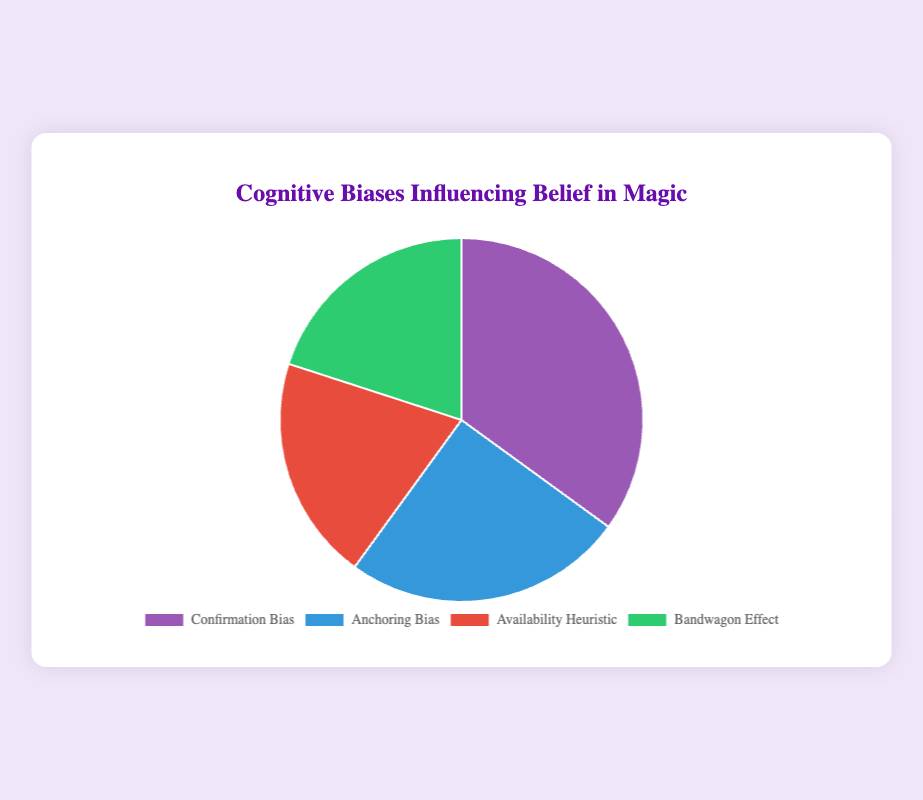What percentage of people are influenced by Confirmation Bias in their belief in magic? The percentage influenced by Confirmation Bias is indicated directly in the pie chart. According to the chart, it shows a slice labeled Confirmation Bias with this value.
Answer: 35% What is the total percentage of people influenced by Availability Heuristic and Bandwagon Effect combined? To find the combined percentage, add the two individual percentages: 20% (Availability Heuristic) + 20% (Bandwagon Effect) = 40%.
Answer: 40% Which cognitive bias has the second largest influence on belief in magic? By observing the sizes of the slices in the pie chart, the second largest slice after Confirmation Bias (35%) is Anchoring Bias (25%).
Answer: Anchoring Bias How much larger is the influence of Confirmation Bias compared to Availability Heuristic? Subtract the percentage of Availability Heuristic from Confirmation Bias: 35% - 20% = 15%.
Answer: 15% If you were to combine the percentages of the two least influential biases, what would you get? The two least influential biases are Availability Heuristic and Bandwagon Effect, both at 20%. Combining them gives: 20% + 20% = 40%.
Answer: 40% What color represents the Anchoring Bias in the pie chart? The pie chart uses specific colors for each segment. Anchoring Bias is represented in blue.
Answer: Blue Which biases are equally influential in belief in magic? According to the pie chart, the Availability Heuristic and Bandwagon Effect each occupy 20% of the chart, indicating equal influence.
Answer: Availability Heuristic and Bandwagon Effect What is the difference in percentage between the most influential bias and the least influential bias? The most influential bias is Confirmation Bias (35%), and the least influential biases are Availability Heuristic and Bandwagon Effect (20%). The difference is: 35% - 20% = 15%.
Answer: 15% What is the average percentage influence of all the cognitive biases shown? Add up all the percentages and divide by the number of biases: (35% + 25% + 20% + 20%) / 4 = 100% / 4 = 25%.
Answer: 25% If the influence of each category was doubled, what would be the new percentage of Reserved Bias in the total? First, double each current percentage: 
- Confirmation Bias: 35% * 2 = 70% 
- Anchoring Bias: 25% * 2 = 50% 
- Availability Heuristic: 20% * 2 = 40% 
- Bandwagon Effect: 20% * 2 = 40% 
The new total would be 70% + 50% + 40% + 40% = 200%.
Answer: 40% 